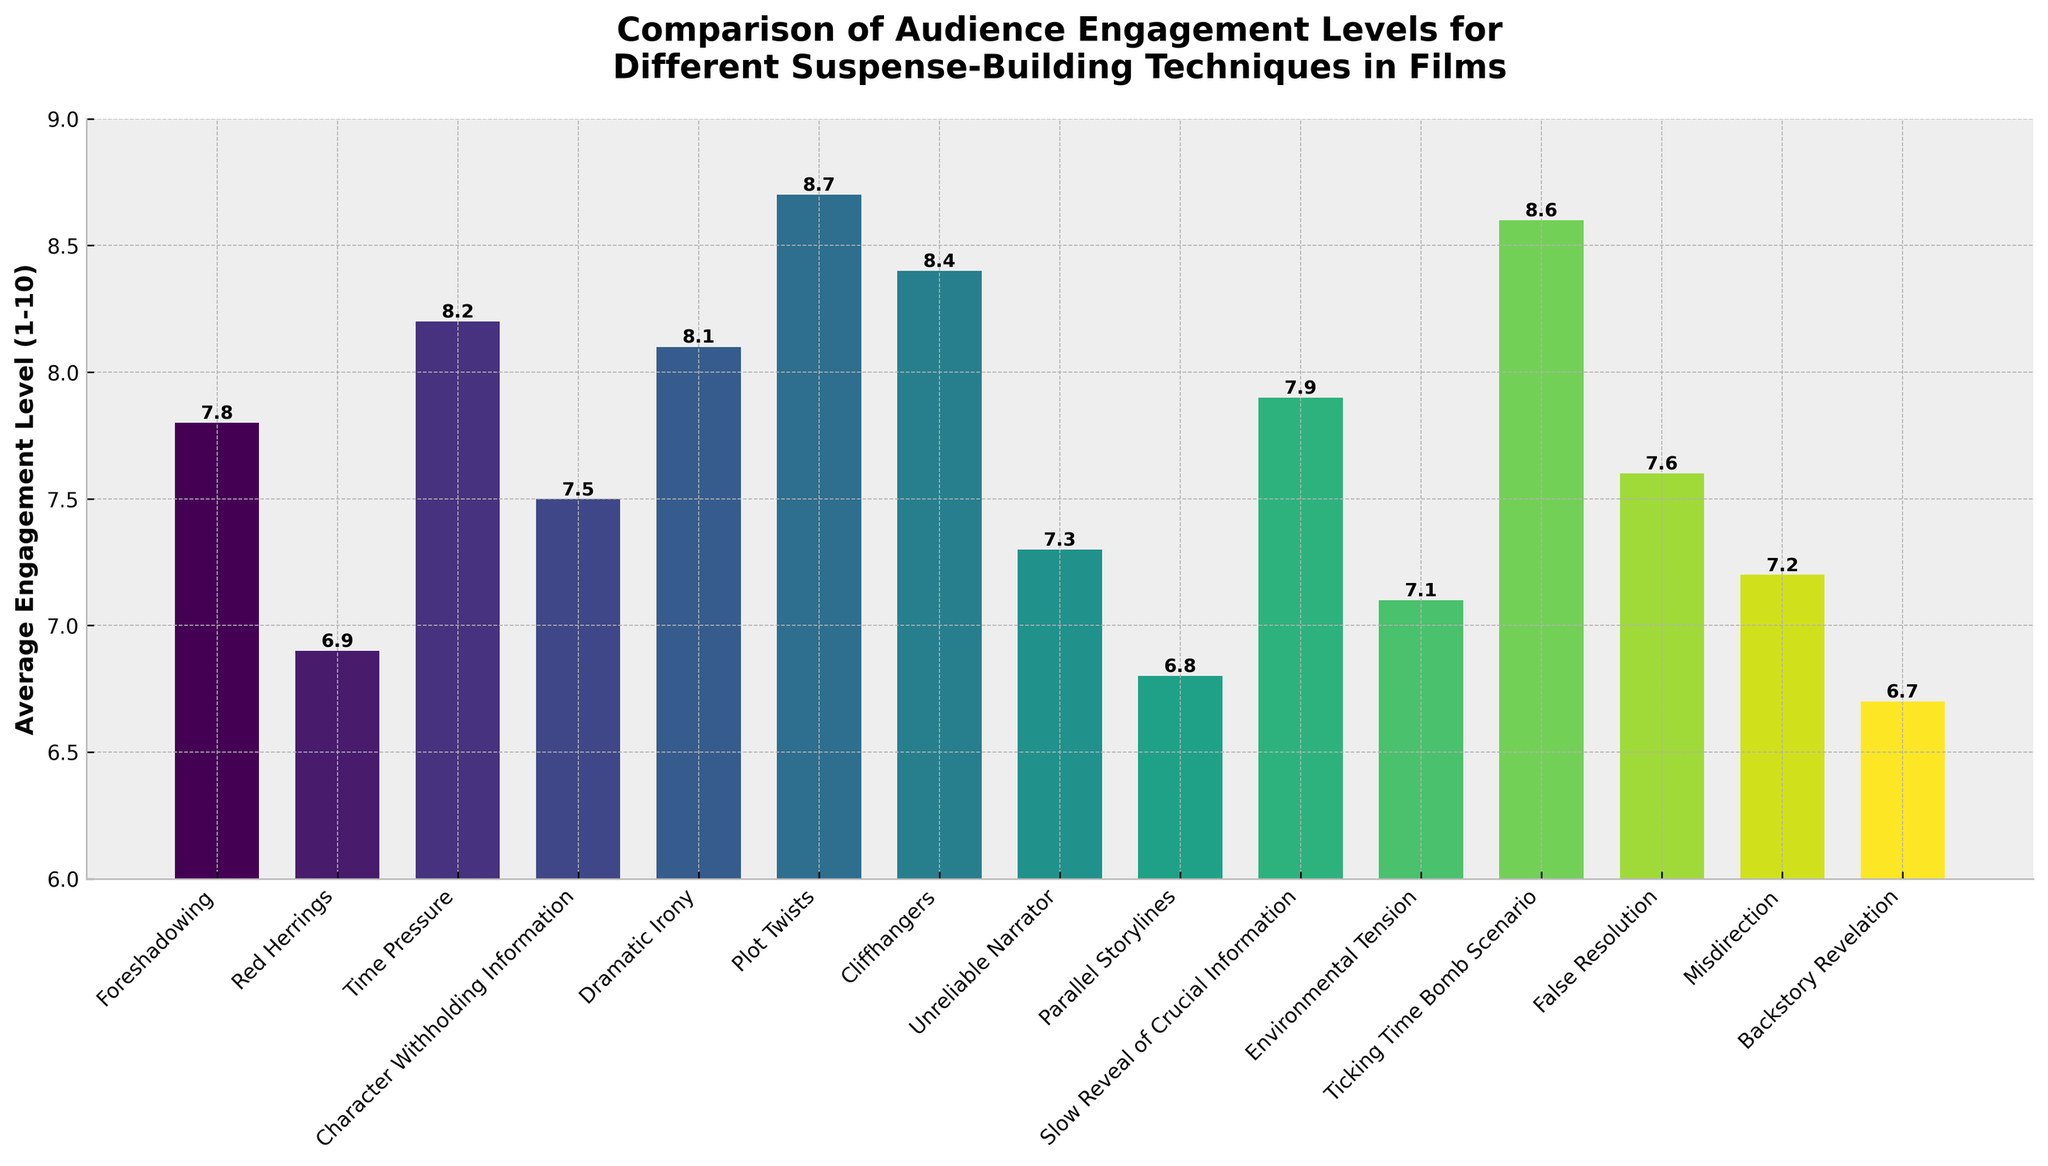Which suspense-building technique has the highest average engagement level? The bar representing 'Plot Twists' has the highest height in the chart, indicating the highest average engagement level of 8.7.
Answer: Plot Twists Which suspense-building technique has the lowest average engagement level? The bar for 'Backstory Revelation' is the shortest, indicating the lowest average engagement level of 6.7.
Answer: Backstory Revelation What is the difference in engagement levels between 'Time Pressure' and 'Environmental Tension'? 'Time Pressure' has an engagement level of 8.2, and 'Environmental Tension' has 7.1. The difference is 8.2 - 7.1 = 1.1.
Answer: 1.1 Is the engagement level of 'Cliffhangers' greater than 'Dramatic Irony'? The bar for 'Cliffhangers' is slightly higher than the one for 'Dramatic Irony,' indicating an engagement level of 8.4, which is greater than 'Dramatic Irony' with 8.1.
Answer: Yes What is the average engagement level of 'Red Herrings', 'Misdirection', and 'Unreliable Narrator'? Adding the engagement levels: 6.9 + 7.2 + 7.3 = 21.4. The average is 21.4 / 3 = 7.13.
Answer: 7.13 Which technique has a higher engagement level: 'Foreshadowing' or 'Slow Reveal of Crucial Information'? The bar for 'Slow Reveal of Crucial Information' is slightly higher than 'Foreshadowing,' indicating engagement levels of 7.9 and 7.8, respectively.
Answer: Slow Reveal of Crucial Information Rank 'Ticking Time Bomb Scenario', 'Plot Twists', and 'Cliffhangers' in terms of engagement level from highest to lowest. The engagement levels are: 'Plot Twists' (8.7), 'Ticking Time Bomb Scenario' (8.6), and 'Cliffhangers' (8.4). Thus, the rank is: 1. Plot Twists 2. Ticking Time Bomb Scenario 3. Cliffhangers.
Answer: Plot Twists, Ticking Time Bomb Scenario, Cliffhangers What is the combined average engagement level of the techniques that have engagement levels lower than 7.0? Techniques below 7.0 are 'Red Herrings' (6.9), 'Parallel Storylines' (6.8), and 'Backstory Revelation' (6.7). Sum is 6.9 + 6.8 + 6.7 = 20.4. The average is 20.4 / 3 = 6.8.
Answer: 6.8 Which visual cue indicates the highest engagement level on the chart? The highest bar, representing 'Plot Twists,' is positioned highest on the vertical axis at an engagement level of 8.7.
Answer: The highest bar 